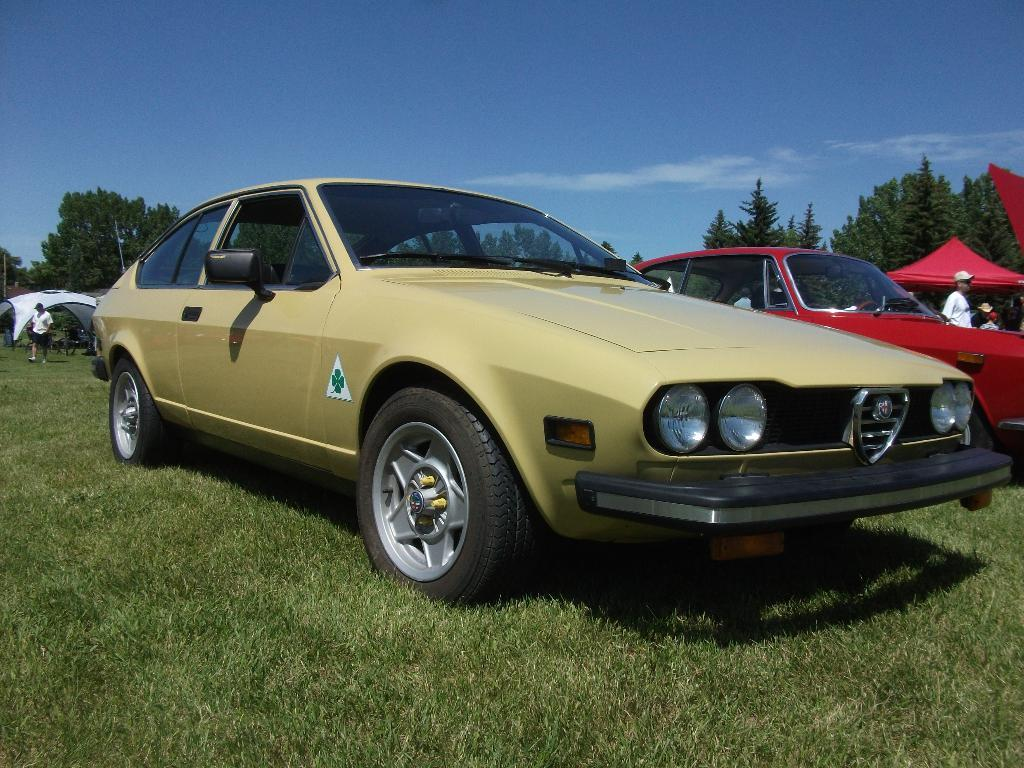Who or what can be seen in the image? There are people in the image. What else is present in the image besides people? There are vehicles, grass, tents, trees, and the sky visible in the image. Can you describe the setting of the image? The image appears to be set outdoors, with grass, trees, and tents present. What might be the purpose of the tents in the image? The tents could be used for shelter or as a gathering place for the people in the image. What color are the eyes of the person in the image? There are no visible eyes in the image, as the people are not shown in close-up or with their faces clearly visible. Is this image taken in a park? The provided facts do not mention any specific location or setting, so it cannot be definitively determined if the image was taken in a park. 